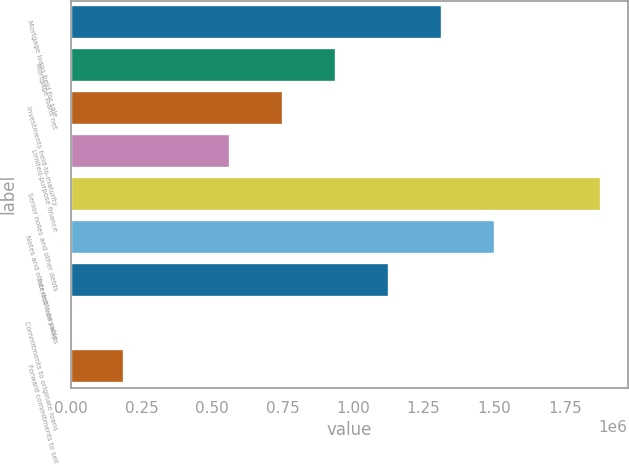Convert chart. <chart><loc_0><loc_0><loc_500><loc_500><bar_chart><fcel>Mortgage loans held for sale<fcel>Mortgage loans net<fcel>Investments held-to-maturity<fcel>Limited-purpose finance<fcel>Senior notes and other debts<fcel>Notes and other debts payable<fcel>Interest rate swaps<fcel>Commitments to originate loans<fcel>Forward commitments to sell<nl><fcel>1.31525e+06<fcel>939530<fcel>751669<fcel>563809<fcel>1.87883e+06<fcel>1.50311e+06<fcel>1.12739e+06<fcel>229<fcel>188089<nl></chart> 